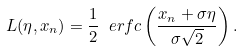Convert formula to latex. <formula><loc_0><loc_0><loc_500><loc_500>L ( \eta , x _ { n } ) = \frac { 1 } { 2 } \ e r f c \left ( \frac { x _ { n } + \sigma \eta } { \sigma \sqrt { 2 } } \right ) .</formula> 